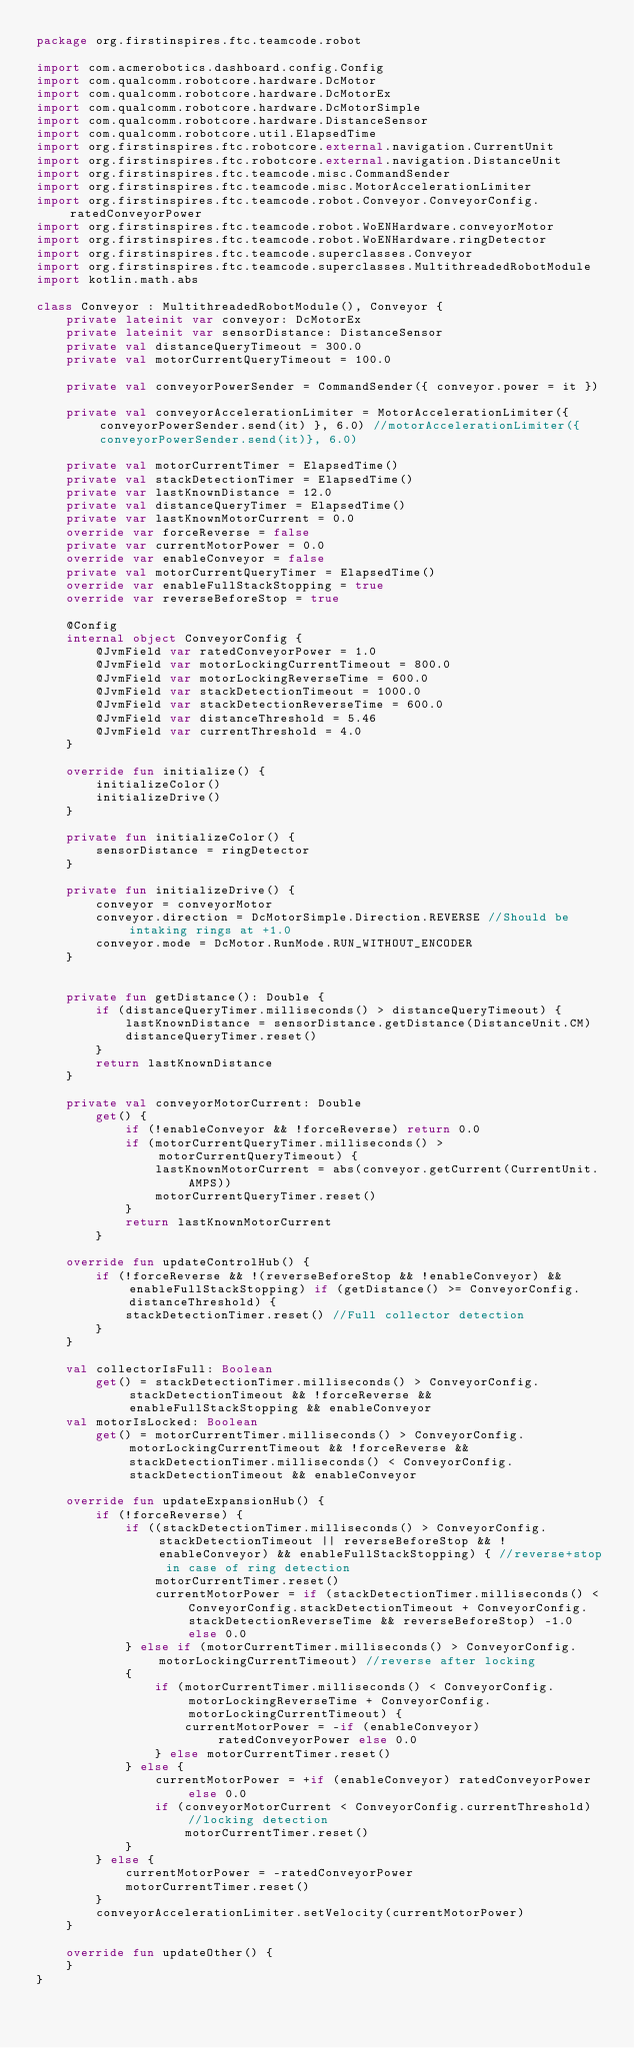Convert code to text. <code><loc_0><loc_0><loc_500><loc_500><_Kotlin_>package org.firstinspires.ftc.teamcode.robot

import com.acmerobotics.dashboard.config.Config
import com.qualcomm.robotcore.hardware.DcMotor
import com.qualcomm.robotcore.hardware.DcMotorEx
import com.qualcomm.robotcore.hardware.DcMotorSimple
import com.qualcomm.robotcore.hardware.DistanceSensor
import com.qualcomm.robotcore.util.ElapsedTime
import org.firstinspires.ftc.robotcore.external.navigation.CurrentUnit
import org.firstinspires.ftc.robotcore.external.navigation.DistanceUnit
import org.firstinspires.ftc.teamcode.misc.CommandSender
import org.firstinspires.ftc.teamcode.misc.MotorAccelerationLimiter
import org.firstinspires.ftc.teamcode.robot.Conveyor.ConveyorConfig.ratedConveyorPower
import org.firstinspires.ftc.teamcode.robot.WoENHardware.conveyorMotor
import org.firstinspires.ftc.teamcode.robot.WoENHardware.ringDetector
import org.firstinspires.ftc.teamcode.superclasses.Conveyor
import org.firstinspires.ftc.teamcode.superclasses.MultithreadedRobotModule
import kotlin.math.abs

class Conveyor : MultithreadedRobotModule(), Conveyor {
    private lateinit var conveyor: DcMotorEx
    private lateinit var sensorDistance: DistanceSensor
    private val distanceQueryTimeout = 300.0
    private val motorCurrentQueryTimeout = 100.0

    private val conveyorPowerSender = CommandSender({ conveyor.power = it })

    private val conveyorAccelerationLimiter = MotorAccelerationLimiter({ conveyorPowerSender.send(it) }, 6.0) //motorAccelerationLimiter({conveyorPowerSender.send(it)}, 6.0)

    private val motorCurrentTimer = ElapsedTime()
    private val stackDetectionTimer = ElapsedTime()
    private var lastKnownDistance = 12.0
    private val distanceQueryTimer = ElapsedTime()
    private var lastKnownMotorCurrent = 0.0
    override var forceReverse = false
    private var currentMotorPower = 0.0
    override var enableConveyor = false
    private val motorCurrentQueryTimer = ElapsedTime()
    override var enableFullStackStopping = true
    override var reverseBeforeStop = true

    @Config
    internal object ConveyorConfig {
        @JvmField var ratedConveyorPower = 1.0
        @JvmField var motorLockingCurrentTimeout = 800.0
        @JvmField var motorLockingReverseTime = 600.0
        @JvmField var stackDetectionTimeout = 1000.0
        @JvmField var stackDetectionReverseTime = 600.0
        @JvmField var distanceThreshold = 5.46
        @JvmField var currentThreshold = 4.0
    }

    override fun initialize() {
        initializeColor()
        initializeDrive()
    }

    private fun initializeColor() {
        sensorDistance = ringDetector
    }

    private fun initializeDrive() {
        conveyor = conveyorMotor
        conveyor.direction = DcMotorSimple.Direction.REVERSE //Should be intaking rings at +1.0
        conveyor.mode = DcMotor.RunMode.RUN_WITHOUT_ENCODER
    }


    private fun getDistance(): Double {
        if (distanceQueryTimer.milliseconds() > distanceQueryTimeout) {
            lastKnownDistance = sensorDistance.getDistance(DistanceUnit.CM)
            distanceQueryTimer.reset()
        }
        return lastKnownDistance
    }

    private val conveyorMotorCurrent: Double
        get() {
            if (!enableConveyor && !forceReverse) return 0.0
            if (motorCurrentQueryTimer.milliseconds() > motorCurrentQueryTimeout) {
                lastKnownMotorCurrent = abs(conveyor.getCurrent(CurrentUnit.AMPS))
                motorCurrentQueryTimer.reset()
            }
            return lastKnownMotorCurrent
        }

    override fun updateControlHub() {
        if (!forceReverse && !(reverseBeforeStop && !enableConveyor) && enableFullStackStopping) if (getDistance() >= ConveyorConfig.distanceThreshold) {
            stackDetectionTimer.reset() //Full collector detection
        }
    }

    val collectorIsFull: Boolean
        get() = stackDetectionTimer.milliseconds() > ConveyorConfig.stackDetectionTimeout && !forceReverse && enableFullStackStopping && enableConveyor
    val motorIsLocked: Boolean
        get() = motorCurrentTimer.milliseconds() > ConveyorConfig.motorLockingCurrentTimeout && !forceReverse && stackDetectionTimer.milliseconds() < ConveyorConfig.stackDetectionTimeout && enableConveyor

    override fun updateExpansionHub() {
        if (!forceReverse) {
            if ((stackDetectionTimer.milliseconds() > ConveyorConfig.stackDetectionTimeout || reverseBeforeStop && !enableConveyor) && enableFullStackStopping) { //reverse+stop in case of ring detection
                motorCurrentTimer.reset()
                currentMotorPower = if (stackDetectionTimer.milliseconds() < ConveyorConfig.stackDetectionTimeout + ConveyorConfig.stackDetectionReverseTime && reverseBeforeStop) -1.0 else 0.0
            } else if (motorCurrentTimer.milliseconds() > ConveyorConfig.motorLockingCurrentTimeout) //reverse after locking
            {
                if (motorCurrentTimer.milliseconds() < ConveyorConfig.motorLockingReverseTime + ConveyorConfig.motorLockingCurrentTimeout) {
                    currentMotorPower = -if (enableConveyor) ratedConveyorPower else 0.0
                } else motorCurrentTimer.reset()
            } else {
                currentMotorPower = +if (enableConveyor) ratedConveyorPower else 0.0
                if (conveyorMotorCurrent < ConveyorConfig.currentThreshold) //locking detection
                    motorCurrentTimer.reset()
            }
        } else {
            currentMotorPower = -ratedConveyorPower
            motorCurrentTimer.reset()
        }
        conveyorAccelerationLimiter.setVelocity(currentMotorPower)
    }

    override fun updateOther() {
    }
}</code> 